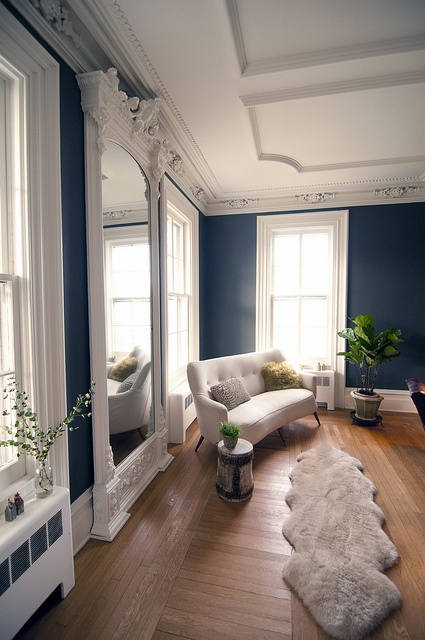Describe the objects in this image and their specific colors. I can see couch in black, lightgray, gray, and darkgray tones, potted plant in black, darkgreen, and gray tones, vase in black and gray tones, vase in black, darkgray, and gray tones, and potted plant in black, gray, and darkgreen tones in this image. 